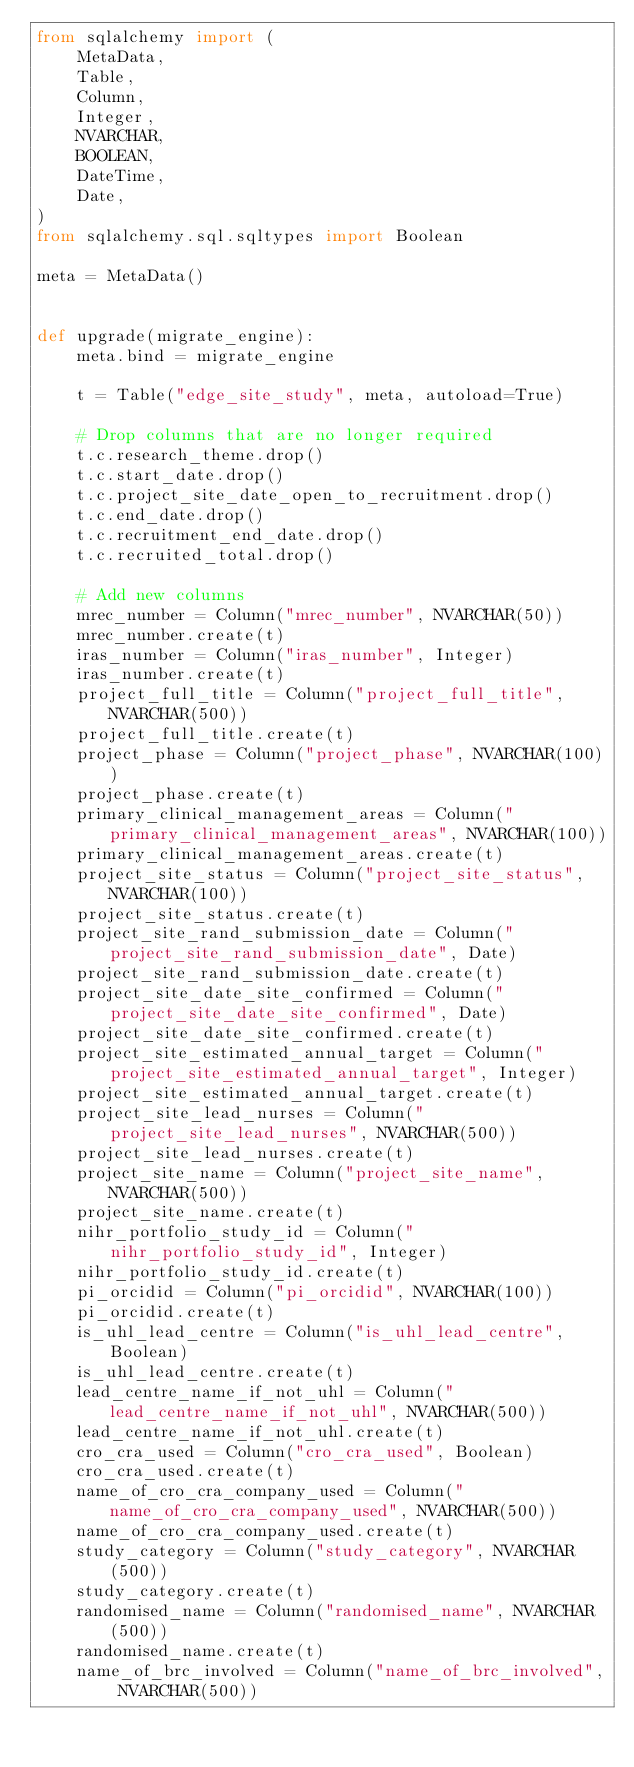Convert code to text. <code><loc_0><loc_0><loc_500><loc_500><_Python_>from sqlalchemy import (
    MetaData,
    Table,
    Column,
    Integer,
    NVARCHAR,
    BOOLEAN,
    DateTime,
    Date,
)
from sqlalchemy.sql.sqltypes import Boolean

meta = MetaData()


def upgrade(migrate_engine):
    meta.bind = migrate_engine

    t = Table("edge_site_study", meta, autoload=True)

    # Drop columns that are no longer required
    t.c.research_theme.drop()
    t.c.start_date.drop()
    t.c.project_site_date_open_to_recruitment.drop()
    t.c.end_date.drop()
    t.c.recruitment_end_date.drop()
    t.c.recruited_total.drop()

    # Add new columns
    mrec_number = Column("mrec_number", NVARCHAR(50))
    mrec_number.create(t)
    iras_number = Column("iras_number", Integer)
    iras_number.create(t)
    project_full_title = Column("project_full_title", NVARCHAR(500))
    project_full_title.create(t)
    project_phase = Column("project_phase", NVARCHAR(100))
    project_phase.create(t)
    primary_clinical_management_areas = Column("primary_clinical_management_areas", NVARCHAR(100))
    primary_clinical_management_areas.create(t)
    project_site_status = Column("project_site_status", NVARCHAR(100))
    project_site_status.create(t)
    project_site_rand_submission_date = Column("project_site_rand_submission_date", Date)
    project_site_rand_submission_date.create(t)
    project_site_date_site_confirmed = Column("project_site_date_site_confirmed", Date)
    project_site_date_site_confirmed.create(t)
    project_site_estimated_annual_target = Column("project_site_estimated_annual_target", Integer)
    project_site_estimated_annual_target.create(t)
    project_site_lead_nurses = Column("project_site_lead_nurses", NVARCHAR(500))
    project_site_lead_nurses.create(t)
    project_site_name = Column("project_site_name", NVARCHAR(500))
    project_site_name.create(t)
    nihr_portfolio_study_id = Column("nihr_portfolio_study_id", Integer)
    nihr_portfolio_study_id.create(t)
    pi_orcidid = Column("pi_orcidid", NVARCHAR(100))
    pi_orcidid.create(t)
    is_uhl_lead_centre = Column("is_uhl_lead_centre", Boolean)
    is_uhl_lead_centre.create(t)
    lead_centre_name_if_not_uhl = Column("lead_centre_name_if_not_uhl", NVARCHAR(500))
    lead_centre_name_if_not_uhl.create(t)
    cro_cra_used = Column("cro_cra_used", Boolean)
    cro_cra_used.create(t)
    name_of_cro_cra_company_used = Column("name_of_cro_cra_company_used", NVARCHAR(500))
    name_of_cro_cra_company_used.create(t)
    study_category = Column("study_category", NVARCHAR(500))
    study_category.create(t)
    randomised_name = Column("randomised_name", NVARCHAR(500))
    randomised_name.create(t)
    name_of_brc_involved = Column("name_of_brc_involved", NVARCHAR(500))</code> 